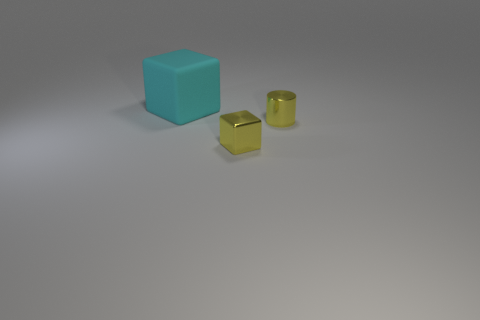Is there any other thing that is the same size as the matte cube?
Offer a terse response. No. There is a big cyan object; does it have the same shape as the tiny yellow object on the left side of the small metal cylinder?
Provide a short and direct response. Yes. Are there any cubes that have the same color as the cylinder?
Your response must be concise. Yes. There is a cube in front of the matte thing; does it have the same size as the tiny metal cylinder?
Your answer should be very brief. Yes. How many yellow things are metal cylinders or rubber things?
Ensure brevity in your answer.  1. What is the material of the block that is behind the small metallic cylinder?
Ensure brevity in your answer.  Rubber. There is a block right of the big cyan rubber block; what number of cyan rubber things are behind it?
Keep it short and to the point. 1. How many metallic objects have the same shape as the cyan rubber thing?
Your answer should be compact. 1. How many yellow shiny cylinders are there?
Keep it short and to the point. 1. There is a cube that is on the right side of the big matte block; what color is it?
Make the answer very short. Yellow. 